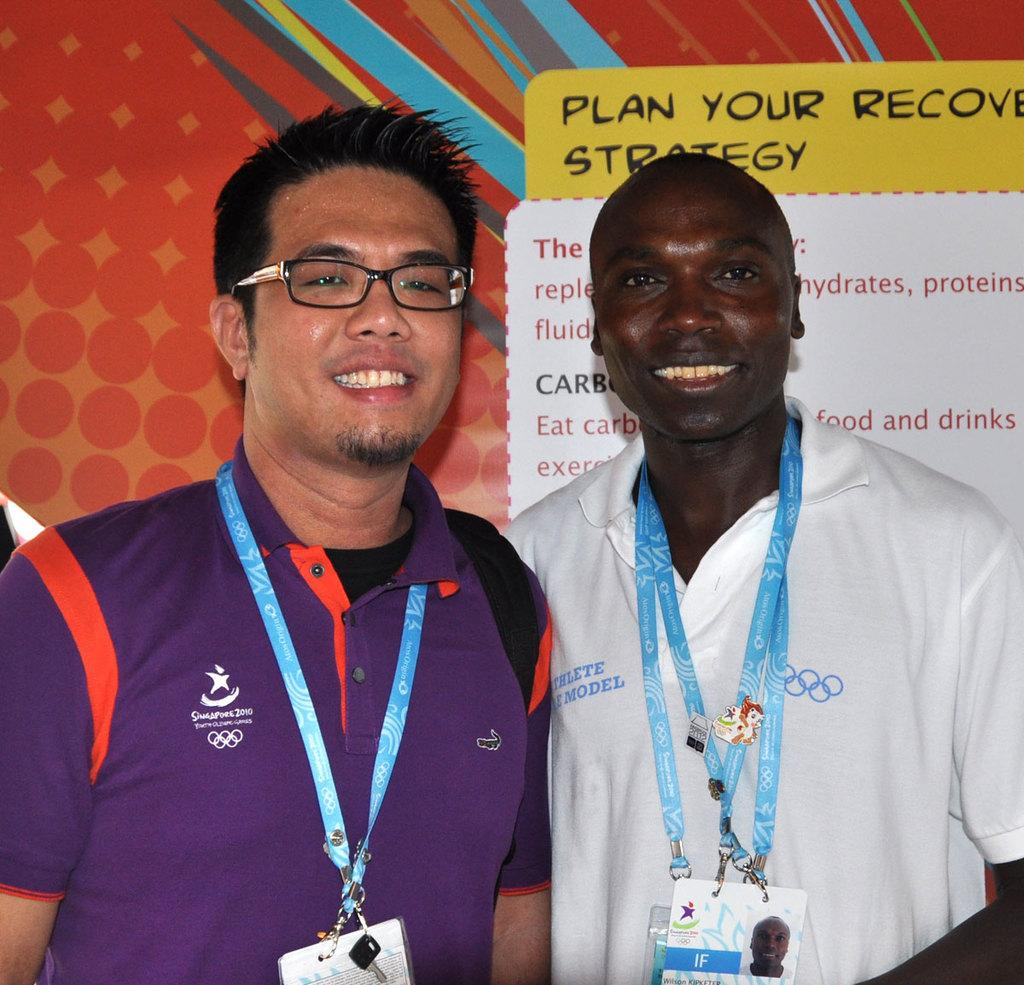What can be seen in the image? There are men standing in the image. What are the men wearing? The men are wearing ID cards. What is visible in the background of the image? There is a board with text visible in the background of the image. What type of rock can be seen in the hands of the men in the image? There is no rock present in the image; the men are wearing ID cards. How many fans are visible in the image? There are no fans present in the image. 